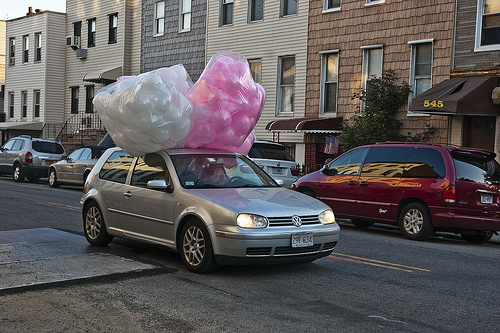<image>
Can you confirm if the balloons is in front of the car? No. The balloons is not in front of the car. The spatial positioning shows a different relationship between these objects. 